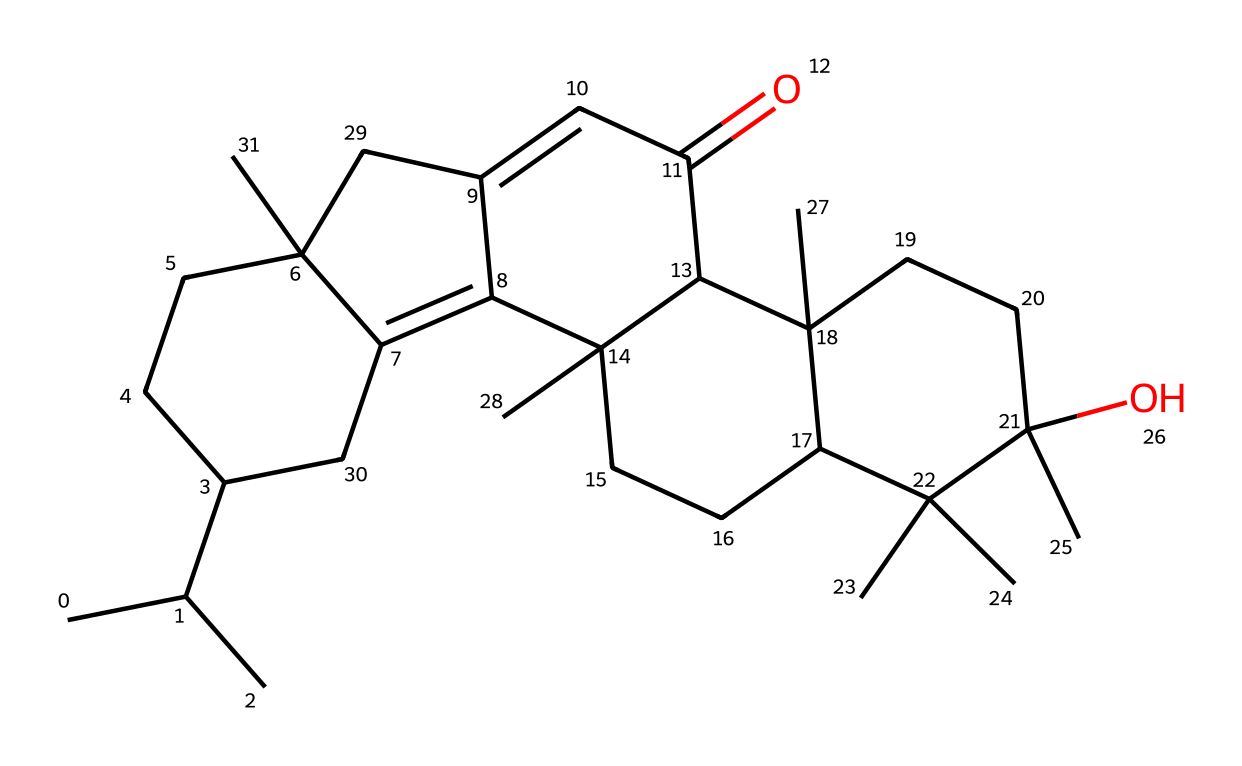what is the primary functional group present in this chemical structure? By analyzing the chemical structure, we can identify the presence of a carbonyl group (C=O) indicative of a ketone functional group within the structure.
Answer: ketone how many carbon atoms are present in this chemical? The SMILES code can be analyzed to count the carbon atoms, which indicates there are 30 carbon atoms in total.
Answer: 30 which type of chemical compound does this belong to? Given the structure and its components, this compound is classified as a resin because it has characteristic features of natural or synthetic resins, typically used in applications like adhesives and varnishes.
Answer: resin does this chemical contain any hydroxyl (-OH) groups? By examining the chemical structure, we can see there is at least one hydroxyl (-OH) group present, which is indicated by the portion showing connectivity that includes oxygen with hydrogen.
Answer: yes what is the significance of this chemical in the context of viola bows? This chemical, being a component of rosin, plays a crucial role in providing friction on the bowstrings, which is important for producing sound when playing the viola.
Answer: friction 